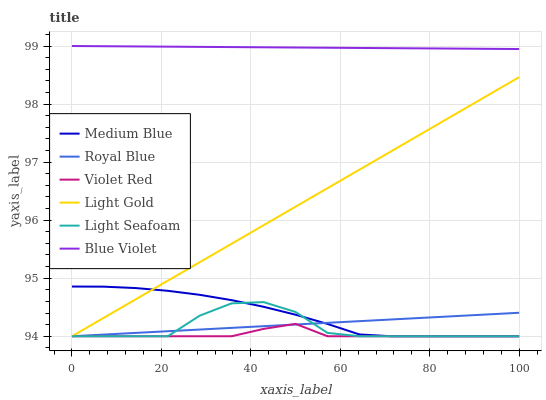Does Violet Red have the minimum area under the curve?
Answer yes or no. Yes. Does Blue Violet have the maximum area under the curve?
Answer yes or no. Yes. Does Medium Blue have the minimum area under the curve?
Answer yes or no. No. Does Medium Blue have the maximum area under the curve?
Answer yes or no. No. Is Light Gold the smoothest?
Answer yes or no. Yes. Is Light Seafoam the roughest?
Answer yes or no. Yes. Is Medium Blue the smoothest?
Answer yes or no. No. Is Medium Blue the roughest?
Answer yes or no. No. Does Violet Red have the lowest value?
Answer yes or no. Yes. Does Blue Violet have the lowest value?
Answer yes or no. No. Does Blue Violet have the highest value?
Answer yes or no. Yes. Does Medium Blue have the highest value?
Answer yes or no. No. Is Light Gold less than Blue Violet?
Answer yes or no. Yes. Is Blue Violet greater than Royal Blue?
Answer yes or no. Yes. Does Light Gold intersect Violet Red?
Answer yes or no. Yes. Is Light Gold less than Violet Red?
Answer yes or no. No. Is Light Gold greater than Violet Red?
Answer yes or no. No. Does Light Gold intersect Blue Violet?
Answer yes or no. No. 